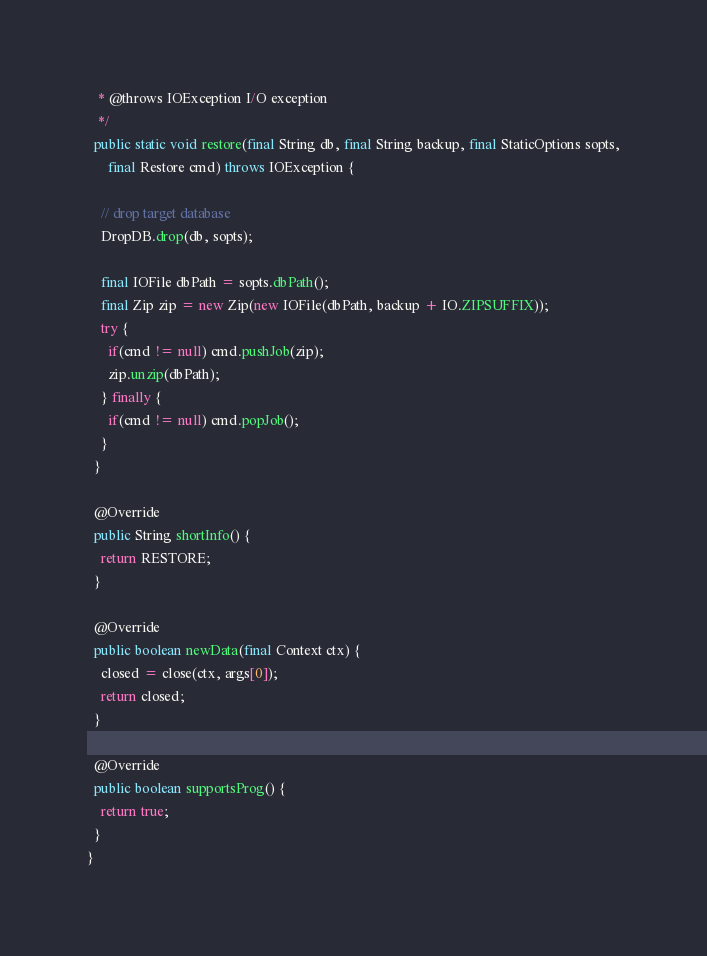Convert code to text. <code><loc_0><loc_0><loc_500><loc_500><_Java_>   * @throws IOException I/O exception
   */
  public static void restore(final String db, final String backup, final StaticOptions sopts,
      final Restore cmd) throws IOException {

    // drop target database
    DropDB.drop(db, sopts);

    final IOFile dbPath = sopts.dbPath();
    final Zip zip = new Zip(new IOFile(dbPath, backup + IO.ZIPSUFFIX));
    try {
      if(cmd != null) cmd.pushJob(zip);
      zip.unzip(dbPath);
    } finally {
      if(cmd != null) cmd.popJob();
    }
  }

  @Override
  public String shortInfo() {
    return RESTORE;
  }

  @Override
  public boolean newData(final Context ctx) {
    closed = close(ctx, args[0]);
    return closed;
  }

  @Override
  public boolean supportsProg() {
    return true;
  }
}
</code> 